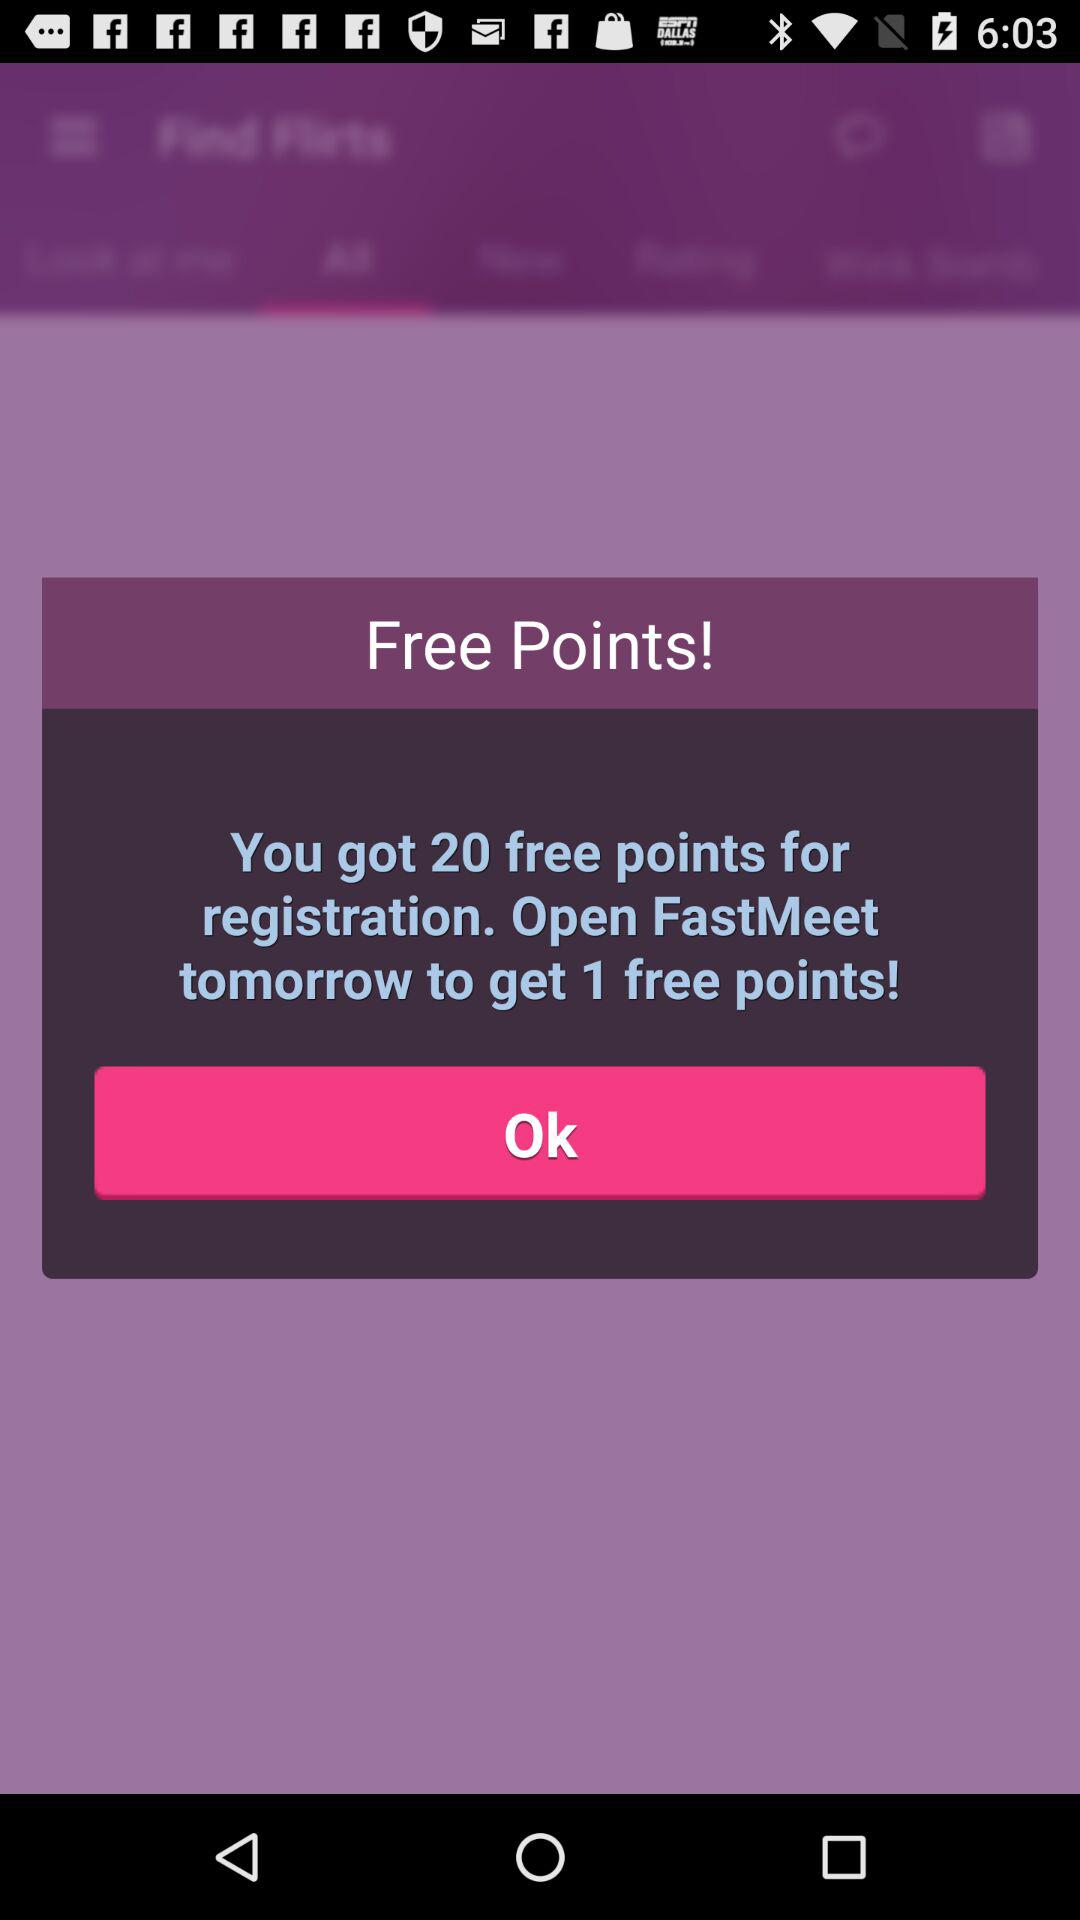How many more free points can I get by opening FastMeet tomorrow?
Answer the question using a single word or phrase. 1 